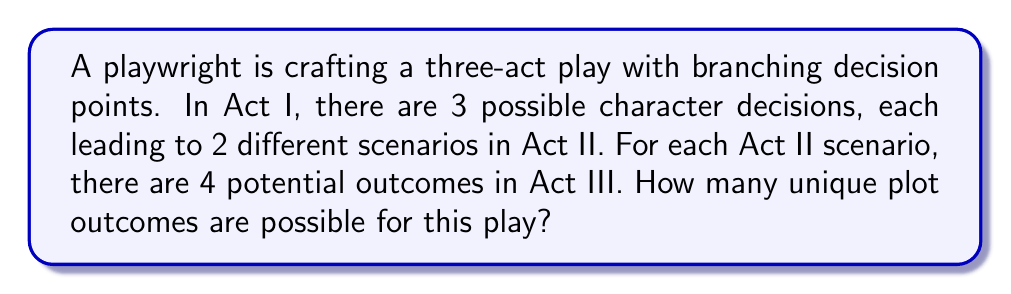Can you answer this question? Let's break this down step-by-step:

1) First, we need to understand the structure of the play:
   - Act I: 3 possible decisions
   - Act II: 2 scenarios for each Act I decision
   - Act III: 4 potential outcomes for each Act II scenario

2) This structure forms a tree-like pattern, where each decision leads to multiple possibilities in the next act.

3) To find the total number of unique plot outcomes, we need to multiply the number of possibilities at each stage:

   $$ \text{Total Outcomes} = (\text{Act I decisions}) \times (\text{Act II scenarios per Act I decision}) \times (\text{Act III outcomes per Act II scenario}) $$

4) Plugging in the numbers:

   $$ \text{Total Outcomes} = 3 \times 2 \times 4 $$

5) Calculating:

   $$ \text{Total Outcomes} = 24 $$

This multiplication principle is a fundamental concept in combinatorics, used when we have a sequence of independent choices.
Answer: 24 